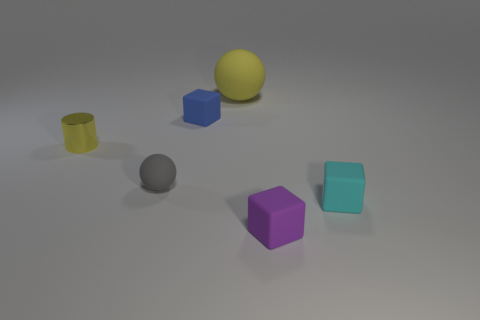Add 3 green metal things. How many objects exist? 9 Subtract all balls. How many objects are left? 4 Subtract all small rubber spheres. Subtract all small metallic cylinders. How many objects are left? 4 Add 3 yellow rubber spheres. How many yellow rubber spheres are left? 4 Add 4 tiny yellow spheres. How many tiny yellow spheres exist? 4 Subtract 0 blue spheres. How many objects are left? 6 